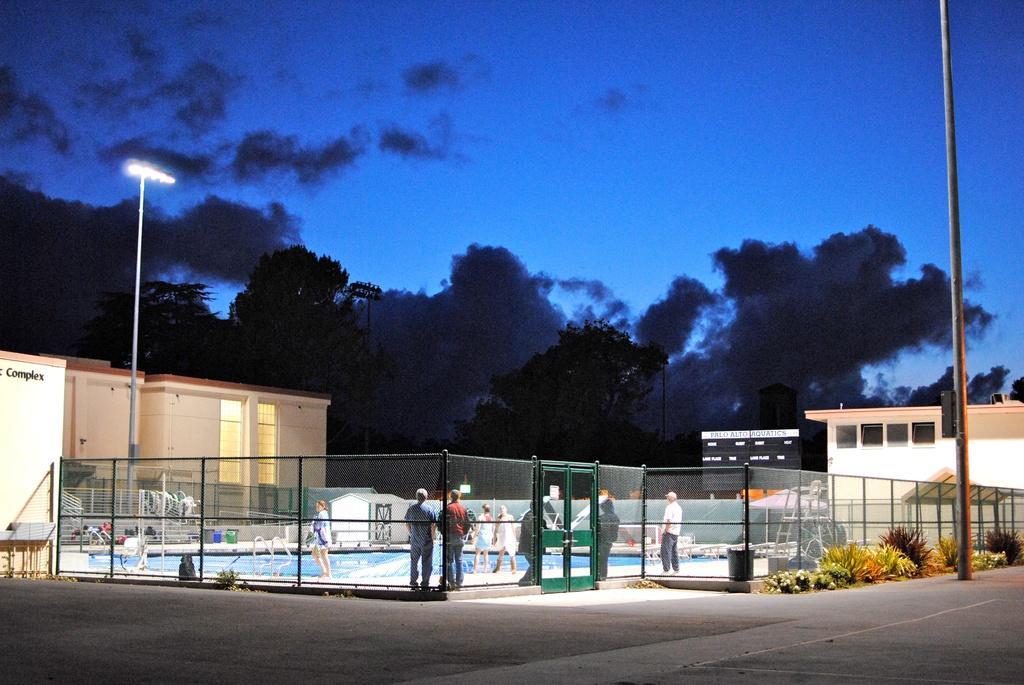In one or two sentences, can you explain what this image depicts? In this image, We can see a electrical pole and another electrical pole which includes a streets lights after that i can see few people standing in a court and i can see few trees and blue sky next they are few trees which are planted outside the court and i can see stool a dust bin. 